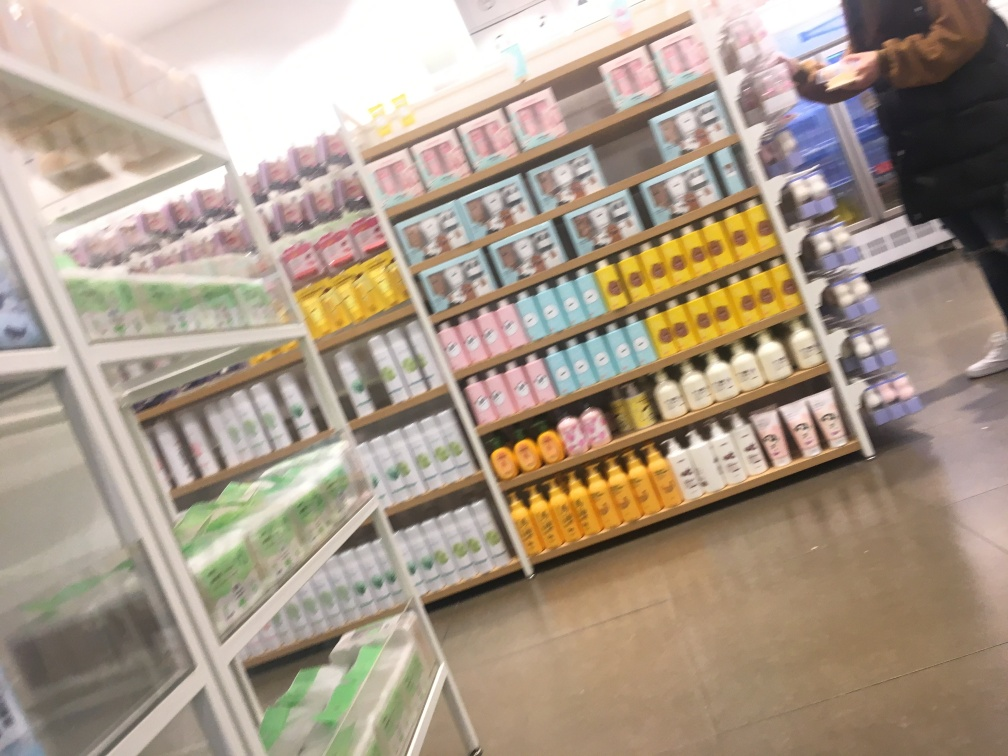How is the background in this image? A. unclear B. well-defined C. sharp D. clear The background in the image is best described as 'unclear' due to the apparent motion blur and lack of sharpness, making details difficult to distinguish. This is most likely a result of camera movement during exposure or a focus issue. 